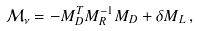<formula> <loc_0><loc_0><loc_500><loc_500>\mathcal { M } _ { \nu } = - M _ { D } ^ { T } M _ { R } ^ { - 1 } M _ { D } + \delta M _ { L } \, ,</formula> 